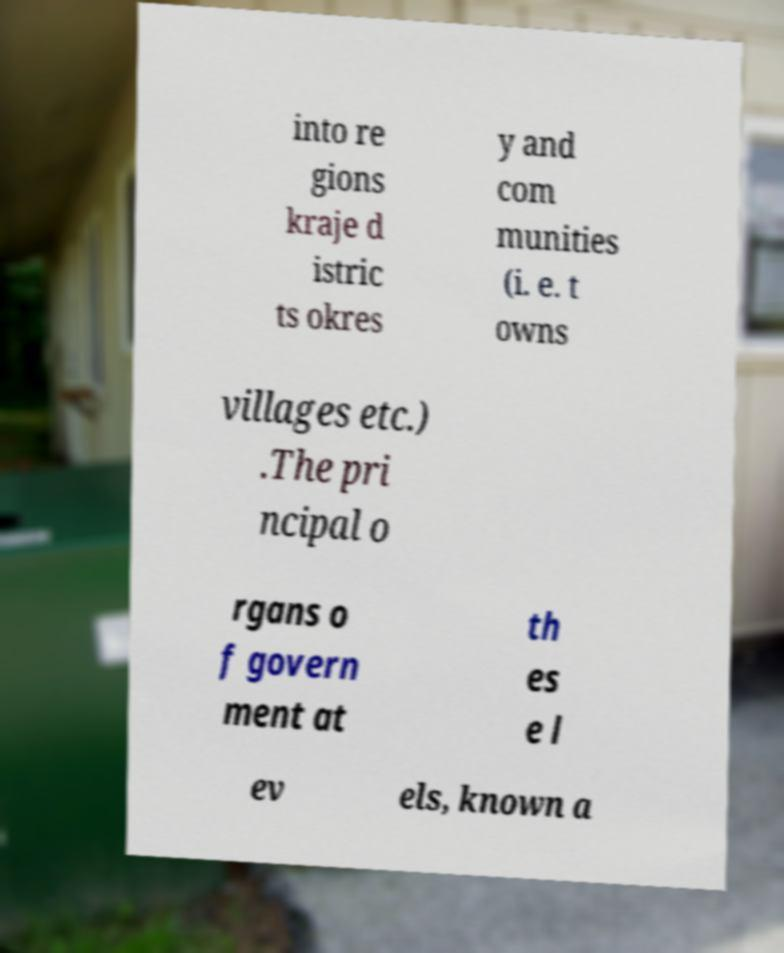Can you accurately transcribe the text from the provided image for me? into re gions kraje d istric ts okres y and com munities (i. e. t owns villages etc.) .The pri ncipal o rgans o f govern ment at th es e l ev els, known a 